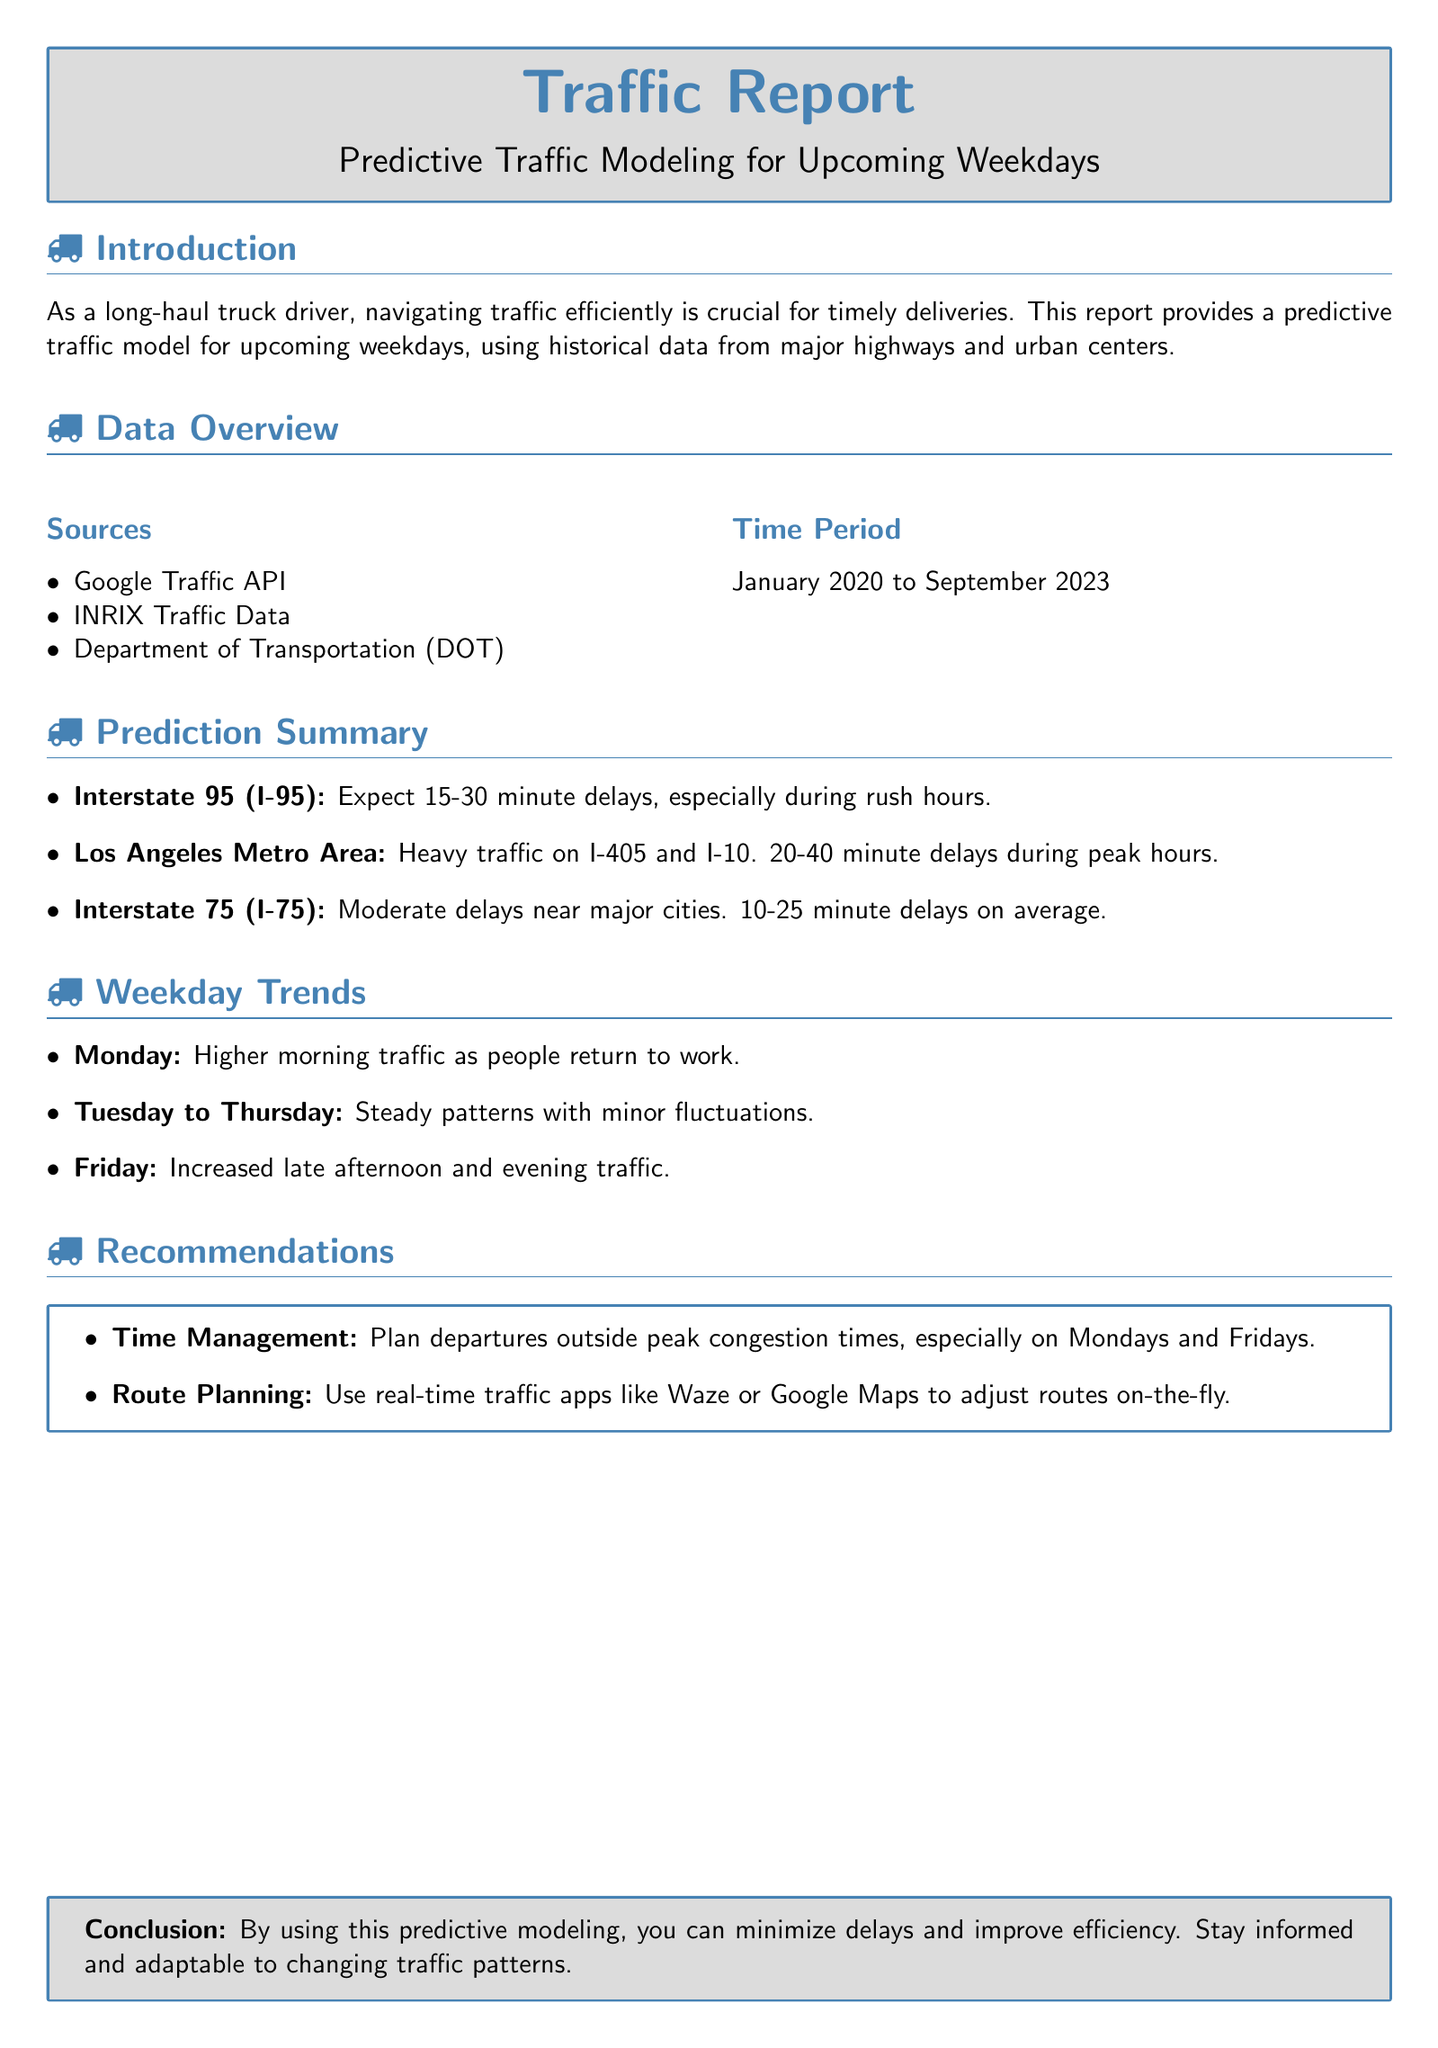what is the data source used for traffic modeling? The document lists three sources for traffic modeling: Google Traffic API, INRIX Traffic Data, and the Department of Transportation (DOT).
Answer: Google Traffic API, INRIX Traffic Data, DOT what is the time period of the data collected? The collected data spans from January 2020 to September 2023.
Answer: January 2020 to September 2023 what delays are expected on Interstate 95? The report indicates that there are expected delays of 15-30 minutes on Interstate 95, especially during rush hours.
Answer: 15-30 minutes which day has higher morning traffic? The report specifies that Monday has higher morning traffic as people return to work.
Answer: Monday what is the average delay on Interstate 75? On Interstate 75, the average delay is reported as 10-25 minutes.
Answer: 10-25 minutes what traffic pattern is seen from Tuesday to Thursday? The document notes that the traffic patterns from Tuesday to Thursday are steady with minor fluctuations.
Answer: Steady patterns what is recommended for time management? The report recommends planning departures outside peak congestion times, especially on Mondays and Fridays.
Answer: Plan departures outside peak congestion times what real-time traffic apps are suggested for route planning? The document suggests using apps like Waze or Google Maps for real-time traffic updates and route adjustments.
Answer: Waze, Google Maps what is the peak traffic time on Fridays? The report indicates increased traffic is expected in the late afternoon and evening on Fridays.
Answer: Late afternoon and evening 